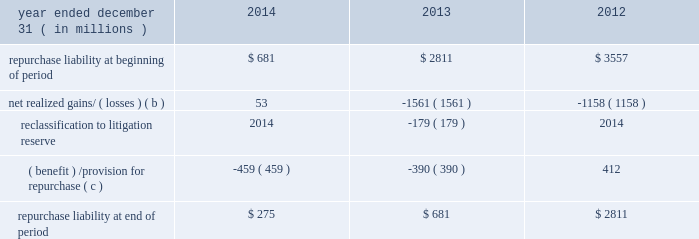Jpmorgan chase & co./2014 annual report 291 therefore , are not recorded on the consolidated balance sheets until settlement date .
The unsettled reverse repurchase agreements and securities borrowing agreements predominantly consist of agreements with regular-way settlement periods .
Loan sales- and securitization-related indemnifications mortgage repurchase liability in connection with the firm 2019s mortgage loan sale and securitization activities with the gses , as described in note 16 , the firm has made representations and warranties that the loans sold meet certain requirements .
The firm has been , and may be , required to repurchase loans and/or indemnify the gses ( e.g. , with 201cmake-whole 201d payments to reimburse the gses for their realized losses on liquidated loans ) .
To the extent that repurchase demands that are received relate to loans that the firm purchased from third parties that remain viable , the firm typically will have the right to seek a recovery of related repurchase losses from the third party .
Generally , the maximum amount of future payments the firm would be required to make for breaches of these representations and warranties would be equal to the unpaid principal balance of such loans that are deemed to have defects that were sold to purchasers ( including securitization-related spes ) plus , in certain circumstances , accrued interest on such loans and certain expense .
The table summarizes the change in the mortgage repurchase liability for each of the periods presented .
Summary of changes in mortgage repurchase liability ( a ) year ended december 31 , ( in millions ) 2014 2013 2012 repurchase liability at beginning of period $ 681 $ 2811 $ 3557 net realized gains/ ( losses ) ( b ) 53 ( 1561 ) ( 1158 ) .
( benefit ) /provision for repurchase ( c ) ( 459 ) ( 390 ) 412 repurchase liability at end of period $ 275 $ 681 $ 2811 ( a ) on october 25 , 2013 , the firm announced that it had reached a $ 1.1 billion agreement with the fhfa to resolve , other than certain limited types of exposures , outstanding and future mortgage repurchase demands associated with loans sold to the gses from 2000 to 2008 .
( b ) presented net of third-party recoveries and included principal losses and accrued interest on repurchased loans , 201cmake-whole 201d settlements , settlements with claimants , and certain related expense .
Make-whole settlements were $ 11 million , $ 414 million and $ 524 million , for the years ended december 31 , 2014 , 2013 and 2012 , respectively .
( c ) included a provision related to new loan sales of $ 4 million , $ 20 million and $ 112 million , for the years ended december 31 , 2014 , 2013 and 2012 , respectively .
Private label securitizations the liability related to repurchase demands associated with private label securitizations is separately evaluated by the firm in establishing its litigation reserves .
On november 15 , 2013 , the firm announced that it had reached a $ 4.5 billion agreement with 21 major institutional investors to make a binding offer to the trustees of 330 residential mortgage-backed securities trusts issued by j.p.morgan , chase , and bear stearns ( 201crmbs trust settlement 201d ) to resolve all representation and warranty claims , as well as all servicing claims , on all trusts issued by j.p .
Morgan , chase , and bear stearns between 2005 and 2008 .
The seven trustees ( or separate and successor trustees ) for this group of 330 trusts have accepted the rmbs trust settlement for 319 trusts in whole or in part and excluded from the settlement 16 trusts in whole or in part .
The trustees 2019 acceptance is subject to a judicial approval proceeding initiated by the trustees , which is pending in new york state court .
In addition , from 2005 to 2008 , washington mutual made certain loan level representations and warranties in connection with approximately $ 165 billion of residential mortgage loans that were originally sold or deposited into private-label securitizations by washington mutual .
Of the $ 165 billion , approximately $ 78 billion has been repaid .
In addition , approximately $ 49 billion of the principal amount of such loans has liquidated with an average loss severity of 59% ( 59 % ) .
Accordingly , the remaining outstanding principal balance of these loans as of december 31 , 2014 , was approximately $ 38 billion , of which $ 8 billion was 60 days or more past due .
The firm believes that any repurchase obligations related to these loans remain with the fdic receivership .
For additional information regarding litigation , see note 31 .
Loans sold with recourse the firm provides servicing for mortgages and certain commercial lending products on both a recourse and nonrecourse basis .
In nonrecourse servicing , the principal credit risk to the firm is the cost of temporary servicing advances of funds ( i.e. , normal servicing advances ) .
In recourse servicing , the servicer agrees to share credit risk with the owner of the mortgage loans , such as fannie mae or freddie mac or a private investor , insurer or guarantor .
Losses on recourse servicing predominantly occur when foreclosure sales proceeds of the property underlying a defaulted loan are less than the sum of the outstanding principal balance , plus accrued interest on the loan and the cost of holding and disposing of the underlying property .
The firm 2019s securitizations are predominantly nonrecourse , thereby effectively transferring the risk of future credit losses to the purchaser of the mortgage-backed securities issued by the trust .
At december 31 , 2014 and 2013 , the unpaid principal balance of loans sold with recourse totaled $ 6.1 billion and $ 7.7 billion , respectively .
The carrying value of the related liability that the firm has recorded , which is representative of the firm 2019s view of the likelihood it .
In 2013 , without the reclassification to litigation reserve , what would the ending balance of repurchase liability bein millions? 
Computations: (681 + 179)
Answer: 860.0. 